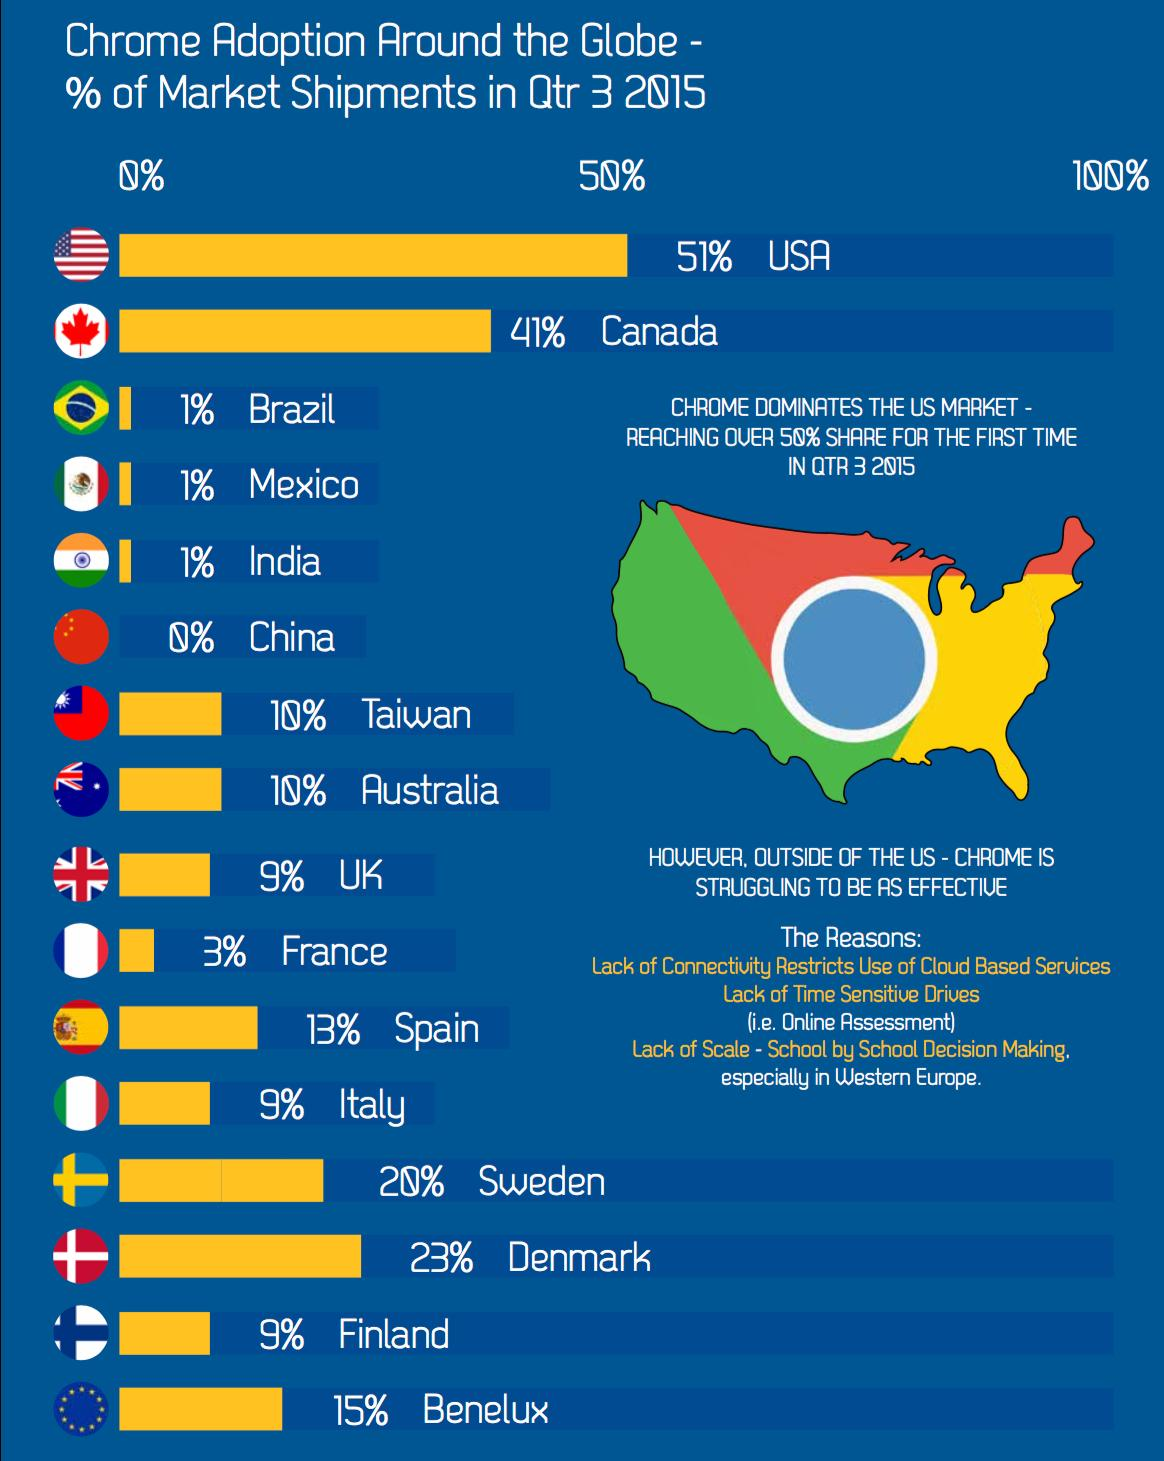Indicate a few pertinent items in this graphic. In Qtr 3 2015, only 1% of the market shipments in India were done through Chrome. In Qtr 3 2015, Canada had the second highest percentage of market shipments done through Chrome, according to the country with the highest percentage. In the third quarter of 2015, 13% of the total market shipments in Spain were done through Chrome. In the third quarter of 2015, 23% of the market shipments in Denmark were made through Chrome. In Qtr 3 of 2015, the country with the lowest percentage of market shipments done through Chrome was China. 